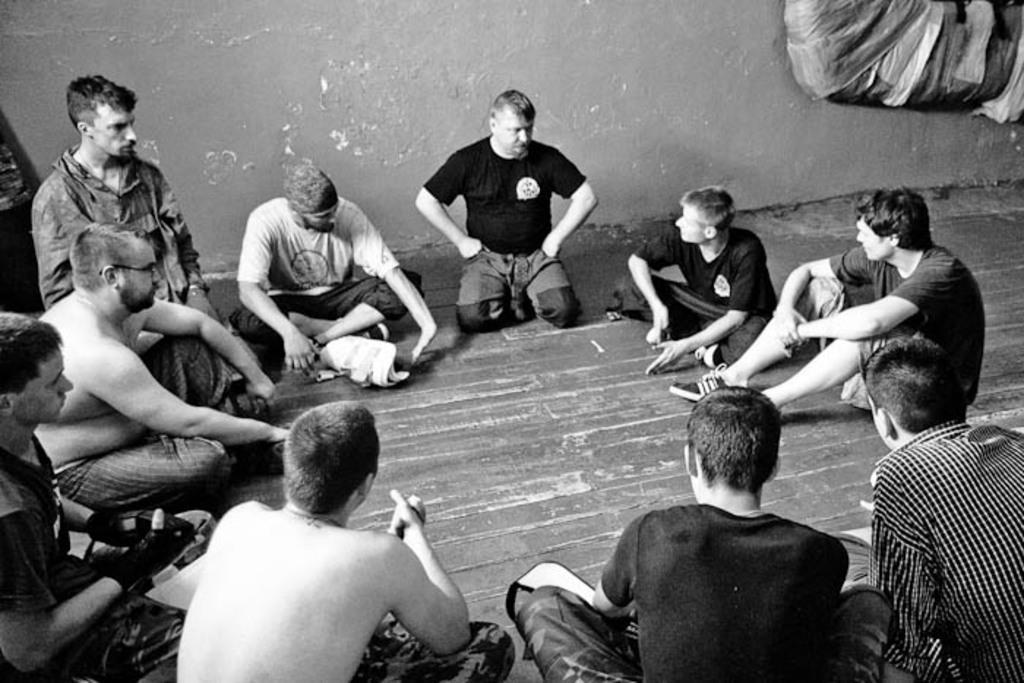Please provide a concise description of this image. In the picture we can see a few men are sitting on the floor and behind them we can see the wall. 